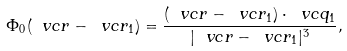Convert formula to latex. <formula><loc_0><loc_0><loc_500><loc_500>\Phi _ { 0 } ( \ v c { r } - \ v c { r } _ { 1 } ) = \frac { ( \ v c { r } - \ v c { r } _ { 1 } ) \cdot \ v c { q } _ { 1 } } { | \ v c { r } - \ v c { r } _ { 1 } | ^ { 3 } } ,</formula> 